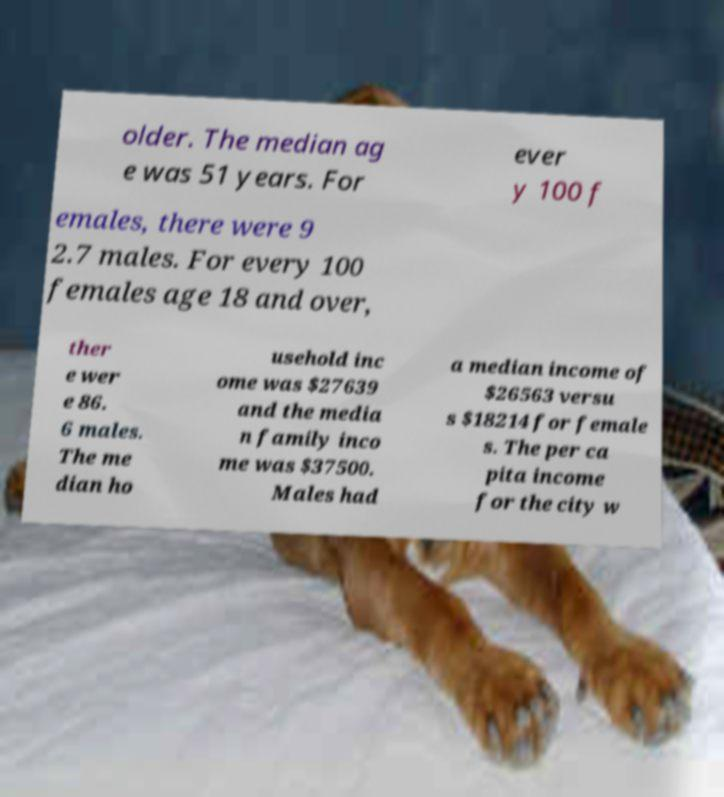I need the written content from this picture converted into text. Can you do that? older. The median ag e was 51 years. For ever y 100 f emales, there were 9 2.7 males. For every 100 females age 18 and over, ther e wer e 86. 6 males. The me dian ho usehold inc ome was $27639 and the media n family inco me was $37500. Males had a median income of $26563 versu s $18214 for female s. The per ca pita income for the city w 